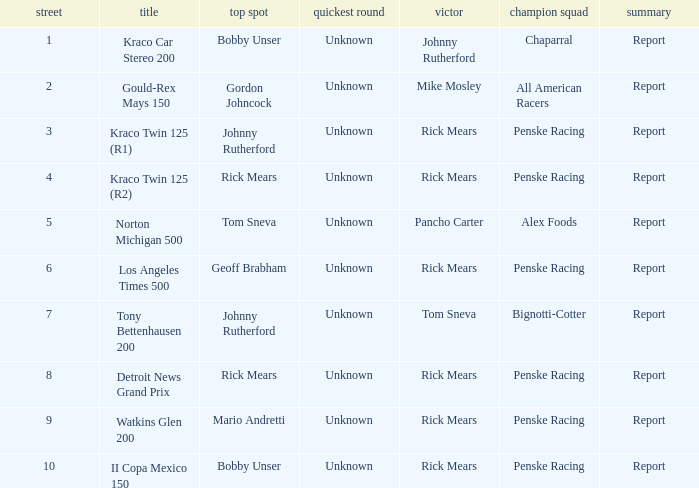Could you parse the entire table as a dict? {'header': ['street', 'title', 'top spot', 'quickest round', 'victor', 'champion squad', 'summary'], 'rows': [['1', 'Kraco Car Stereo 200', 'Bobby Unser', 'Unknown', 'Johnny Rutherford', 'Chaparral', 'Report'], ['2', 'Gould-Rex Mays 150', 'Gordon Johncock', 'Unknown', 'Mike Mosley', 'All American Racers', 'Report'], ['3', 'Kraco Twin 125 (R1)', 'Johnny Rutherford', 'Unknown', 'Rick Mears', 'Penske Racing', 'Report'], ['4', 'Kraco Twin 125 (R2)', 'Rick Mears', 'Unknown', 'Rick Mears', 'Penske Racing', 'Report'], ['5', 'Norton Michigan 500', 'Tom Sneva', 'Unknown', 'Pancho Carter', 'Alex Foods', 'Report'], ['6', 'Los Angeles Times 500', 'Geoff Brabham', 'Unknown', 'Rick Mears', 'Penske Racing', 'Report'], ['7', 'Tony Bettenhausen 200', 'Johnny Rutherford', 'Unknown', 'Tom Sneva', 'Bignotti-Cotter', 'Report'], ['8', 'Detroit News Grand Prix', 'Rick Mears', 'Unknown', 'Rick Mears', 'Penske Racing', 'Report'], ['9', 'Watkins Glen 200', 'Mario Andretti', 'Unknown', 'Rick Mears', 'Penske Racing', 'Report'], ['10', 'II Copa Mexico 150', 'Bobby Unser', 'Unknown', 'Rick Mears', 'Penske Racing', 'Report']]} How many winning drivers in the kraco twin 125 (r2) race were there? 1.0. 